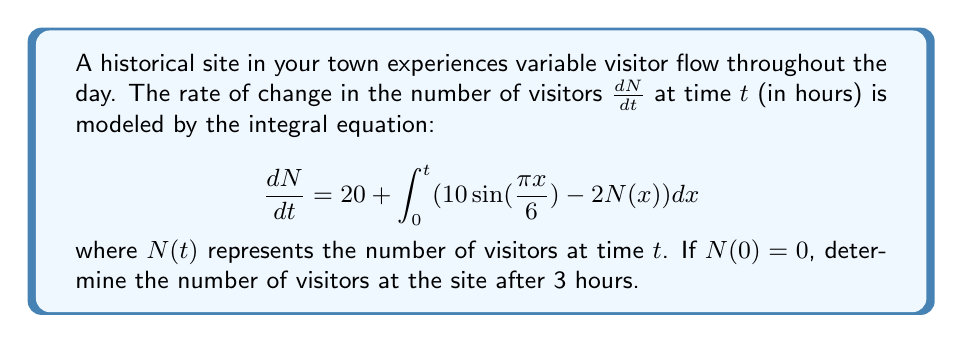Solve this math problem. Let's solve this step-by-step:

1) First, we need to solve the integral equation. Let's differentiate both sides with respect to $t$:

   $$\frac{d^2N}{dt^2} = 10 \sin(\frac{\pi t}{6}) - 2N(t)$$

2) This is a second-order linear differential equation. We can solve it using the method of undetermined coefficients.

3) The general solution will be of the form:
   $$N(t) = A \cos(\frac{\pi t}{6}) + B \sin(\frac{\pi t}{6}) + C$$

4) Substituting this into the differential equation:

   $$-\frac{\pi^2}{36}(A \cos(\frac{\pi t}{6}) + B \sin(\frac{\pi t}{6})) = 10 \sin(\frac{\pi t}{6}) - 2(A \cos(\frac{\pi t}{6}) + B \sin(\frac{\pi t}{6}) + C)$$

5) Comparing coefficients:

   $$-\frac{\pi^2}{36}A - 2A = 0$$
   $$-\frac{\pi^2}{36}B - 2B = 10$$
   $$-2C = 0$$

6) Solving these equations:

   $$A = 0$$
   $$B = -\frac{360}{\pi^2 + 72} \approx -4.48$$
   $$C = 0$$

7) Therefore, the general solution is:

   $$N(t) = -4.48 \sin(\frac{\pi t}{6})$$

8) To find the particular solution, we use the initial condition $N(0) = 0$:

   $$N(0) = -4.48 \sin(0) = 0$$

   This is satisfied, so our solution is complete.

9) To find $N(3)$, we substitute $t = 3$ into our solution:

   $$N(3) = -4.48 \sin(\frac{\pi 3}{6}) = -4.48 \sin(\frac{\pi}{2}) = -4.48$$

10) Since we're dealing with visitors, we need to round to the nearest whole number and take the absolute value.
Answer: 4 visitors 